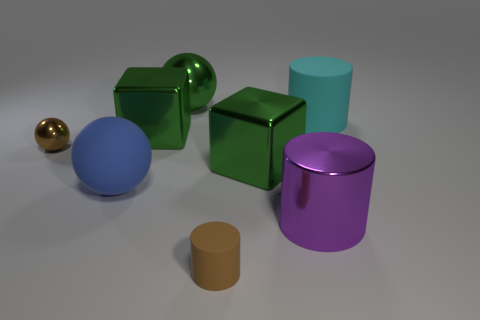How many things are either small brown matte things or large rubber things to the right of the small brown matte cylinder?
Provide a succinct answer. 2. There is a metallic thing that is the same color as the small cylinder; what shape is it?
Ensure brevity in your answer.  Sphere. How many green shiny things have the same size as the green metallic sphere?
Provide a succinct answer. 2. What number of red objects are big rubber cylinders or tiny cylinders?
Keep it short and to the point. 0. There is a brown object that is to the right of the green sphere to the left of the big purple shiny cylinder; what is its shape?
Give a very brief answer. Cylinder. The cyan matte thing that is the same size as the purple cylinder is what shape?
Keep it short and to the point. Cylinder. Are there any other large metallic spheres of the same color as the big metal ball?
Provide a short and direct response. No. Are there the same number of blocks behind the tiny sphere and big matte things in front of the large purple object?
Offer a very short reply. No. Do the small matte object and the large rubber object that is to the right of the big purple object have the same shape?
Give a very brief answer. Yes. How many other objects are the same material as the brown sphere?
Offer a terse response. 4. 